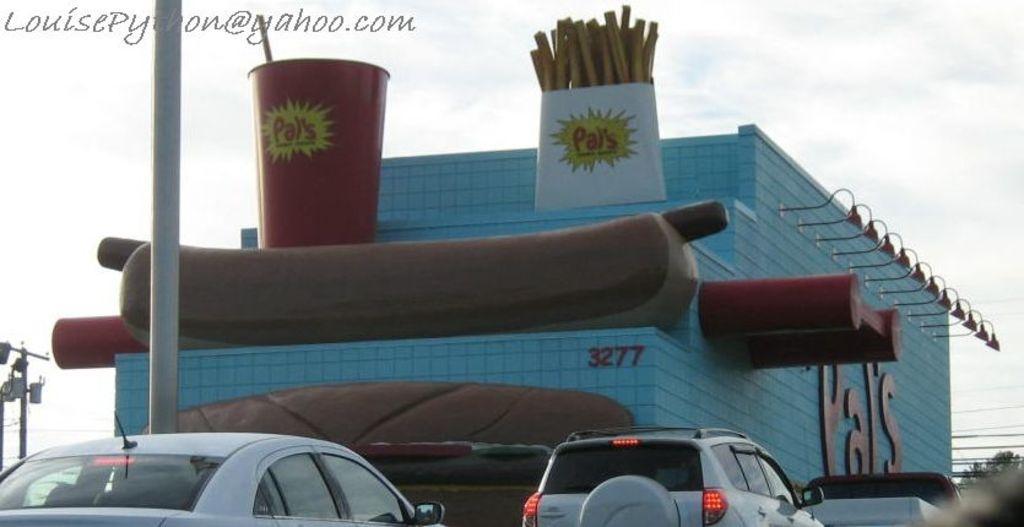Could you give a brief overview of what you see in this image? In the picture I can see a building which has few edible objects placed on it and there are few vehicles beside it and there are few poles in the left corner and there is something written in the left top corner. 